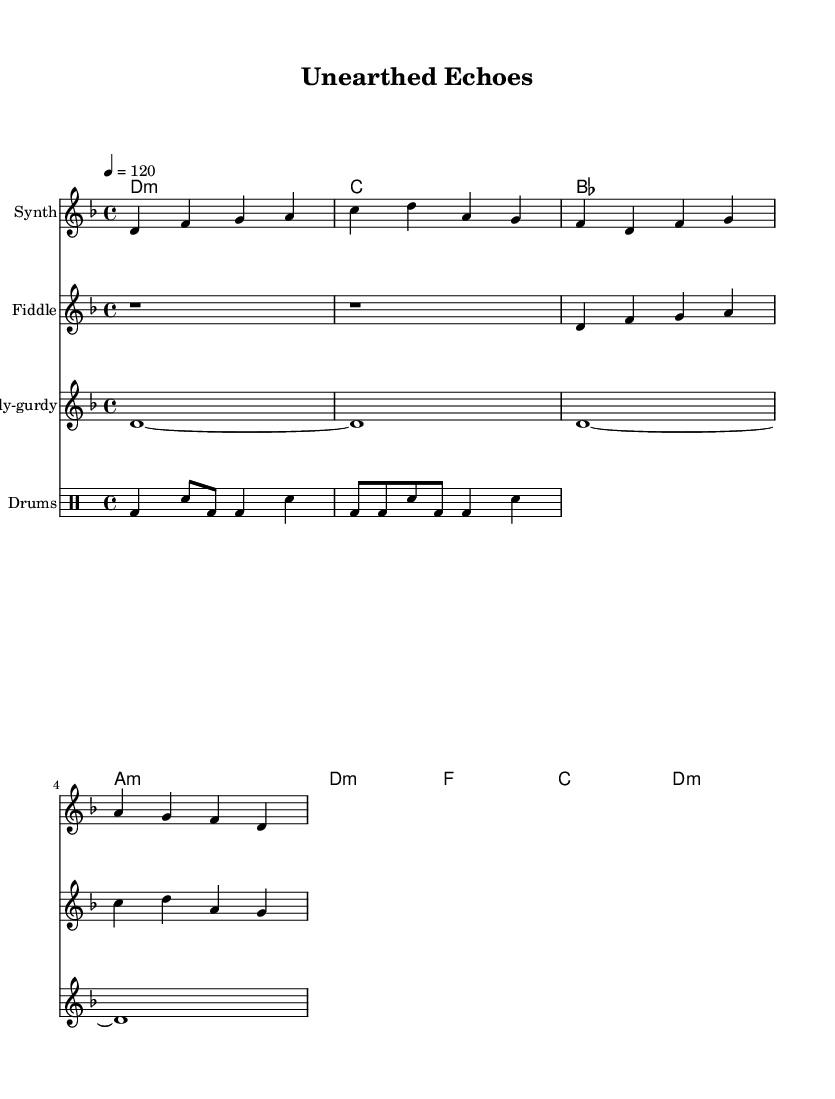What is the key signature of this music? The key signature is D minor, which contains one flat (B flat). This is indicated at the beginning of the sheet music.
Answer: D minor What is the time signature of this piece? The time signature is 4/4, indicating four beats per measure (bar). This is also stated at the beginning of the score.
Answer: 4/4 What is the tempo marking for this composition? The tempo marking indicates a speed of 120 beats per minute, noted as "4 = 120". This means each quarter note gets one beat and there are 120 beats in one minute.
Answer: 120 How many measures are in the synth melody? Counting the measures in the synth melody section reveals there are 4 measures present, as delineated by the vertical lines on the staff.
Answer: 4 What is the primary instrument used for the melody? The primary instrument for the melody is the synth, as indicated clearly by the labeled staff in the sheet music and the specific musical line for it.
Answer: Synth Which traditional instrument is featured alongside electronic elements? The fiddle is the traditional instrument featured in this score which blends with the electronic elements of the synth. This is noted on its dedicated staff in the sheet music.
Answer: Fiddle What type of drums are being used in the composition? The drums part is notated using standard drum notation which typically includes bass drum and snare drum. The presence of varied notations indicates a mix of these instruments in the drum part.
Answer: Bass and snare 